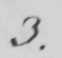What is written in this line of handwriting? 3 . 